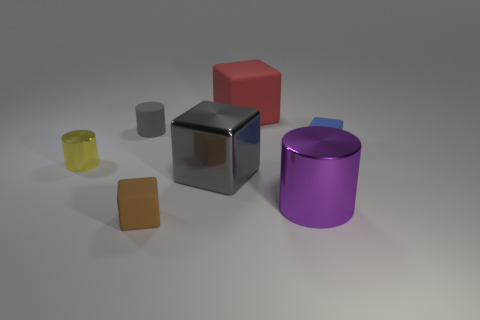Subtract all tiny brown blocks. How many blocks are left? 3 Subtract all brown blocks. How many blocks are left? 3 Add 3 tiny gray matte cylinders. How many objects exist? 10 Subtract all yellow cubes. Subtract all brown cylinders. How many cubes are left? 4 Subtract all cylinders. How many objects are left? 4 Subtract all large gray metal things. Subtract all tiny gray cylinders. How many objects are left? 5 Add 2 yellow metal cylinders. How many yellow metal cylinders are left? 3 Add 7 small yellow things. How many small yellow things exist? 8 Subtract 0 yellow blocks. How many objects are left? 7 